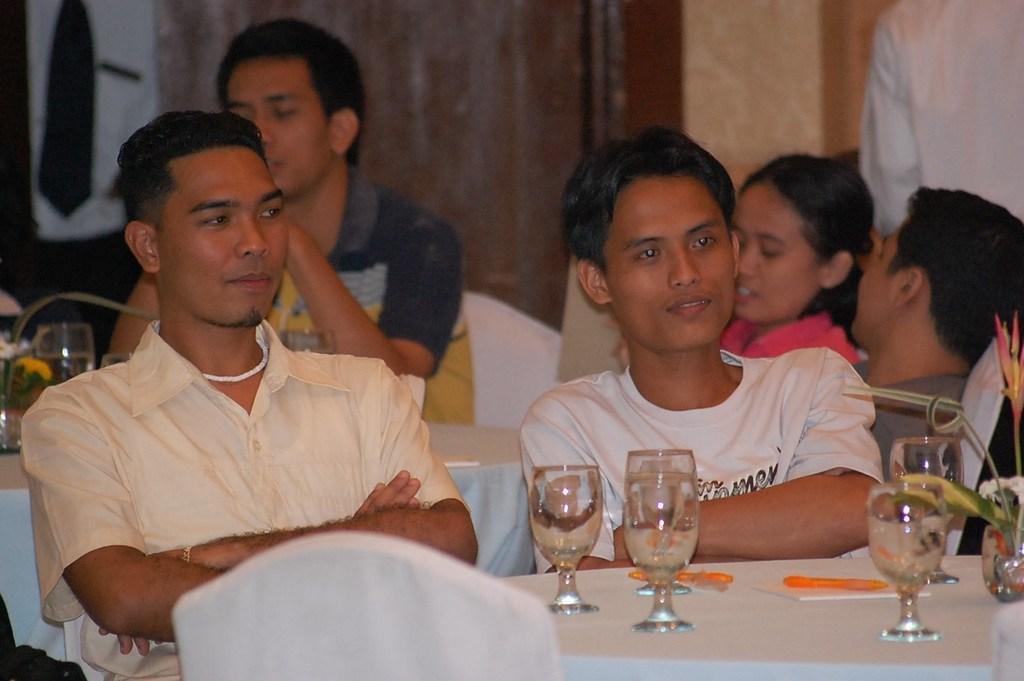Please provide a concise description of this image. In this image I can see persons visible in front of the table , on the table I can see glasses contain water and I can see a leaf visible in the glass on the right side 